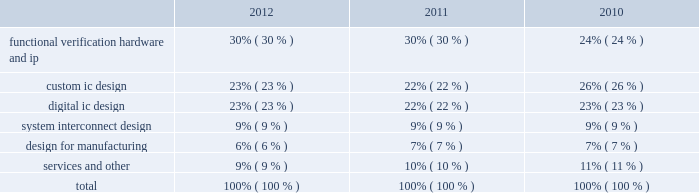Fiscal 2011 , primarily because of increased business levels , an increase in revenue related to the sale and lease of our hardware products and increased revenue recognized from bookings in prior periods .
Maintenance revenue decreased on a standalone basis during fiscal 2012 as compared to fiscal 2011 , primarily because of the increased allocation to product revenue due to the gradual decline in the average duration of our time-based software license arrangements over the last three years .
Product and maintenance revenue increased during fiscal 2011 , as compared to fiscal 2010 , due to reasons noted above and also due to the increase in revenue from the denali business which we acquired in the second quarter of 2010 .
We expect the aggregate of product and maintenance revenue will increase during fiscal 2013 due to increases in the revenue from our software and ip products , partially offset by an expected decrease in revenue from our hardware products .
Services revenue decreased during fiscal 2012 , as compared to fiscal 2011 , primarily because certain of our design services engineers have been redeployed to internal research and development projects and to assist with pre-sales activities .
Services revenue increased during fiscal 2011 , as compared to fiscal 2010 , primarily because of cash collections from customers on orders fulfilled in years prior to 2011 for which revenue was recognized in fiscal 2011 upon receipt of cash payment , and because of higher utilization rates for our services personnel .
We expect services revenue to decrease during fiscal 2013 , as compared to fiscal 2012 , as we expect certain of our design services engineers will continue to work on internal research and development projects , primarily related or our design ip and vip activities .
Revenue by product group the table shows the percentage of product and related maintenance revenue contributed by each of our five product groups , and services and other during fiscal 2012 , 2011 and 2010: .
As described in note 2 in the notes to consolidated financial statements , certain of our licensing arrangements allow customers the ability to remix among software products .
Additionally , we have arrangements with customers that include a combination of our products , with the actual product selection and number of licensed users to be determined at a later date .
For these arrangements , we estimate the allocation of the revenue to product groups based upon the expected usage of our products .
The actual usage of our products by these customers may differ and , if that proves to be the case , the revenue allocation in the table above would differ .
The changes in the percentage of revenue contributed by the functional verification , hardware and ip product group are generally related to changes in revenue related to our hardware products. .
What is the difference in the percentage of product and related maintenance revenue contributed by the custom ic design product group in 2010 versus 2012? 
Computations: (23% - 26%)
Answer: -0.03. Fiscal 2011 , primarily because of increased business levels , an increase in revenue related to the sale and lease of our hardware products and increased revenue recognized from bookings in prior periods .
Maintenance revenue decreased on a standalone basis during fiscal 2012 as compared to fiscal 2011 , primarily because of the increased allocation to product revenue due to the gradual decline in the average duration of our time-based software license arrangements over the last three years .
Product and maintenance revenue increased during fiscal 2011 , as compared to fiscal 2010 , due to reasons noted above and also due to the increase in revenue from the denali business which we acquired in the second quarter of 2010 .
We expect the aggregate of product and maintenance revenue will increase during fiscal 2013 due to increases in the revenue from our software and ip products , partially offset by an expected decrease in revenue from our hardware products .
Services revenue decreased during fiscal 2012 , as compared to fiscal 2011 , primarily because certain of our design services engineers have been redeployed to internal research and development projects and to assist with pre-sales activities .
Services revenue increased during fiscal 2011 , as compared to fiscal 2010 , primarily because of cash collections from customers on orders fulfilled in years prior to 2011 for which revenue was recognized in fiscal 2011 upon receipt of cash payment , and because of higher utilization rates for our services personnel .
We expect services revenue to decrease during fiscal 2013 , as compared to fiscal 2012 , as we expect certain of our design services engineers will continue to work on internal research and development projects , primarily related or our design ip and vip activities .
Revenue by product group the table shows the percentage of product and related maintenance revenue contributed by each of our five product groups , and services and other during fiscal 2012 , 2011 and 2010: .
As described in note 2 in the notes to consolidated financial statements , certain of our licensing arrangements allow customers the ability to remix among software products .
Additionally , we have arrangements with customers that include a combination of our products , with the actual product selection and number of licensed users to be determined at a later date .
For these arrangements , we estimate the allocation of the revenue to product groups based upon the expected usage of our products .
The actual usage of our products by these customers may differ and , if that proves to be the case , the revenue allocation in the table above would differ .
The changes in the percentage of revenue contributed by the functional verification , hardware and ip product group are generally related to changes in revenue related to our hardware products. .
What is the difference in the percentage of product and related maintenance revenue contributed by the functional verification hardware and ip product group in 2010 versus 2012? 
Computations: (30% - 24%)
Answer: 0.06. 